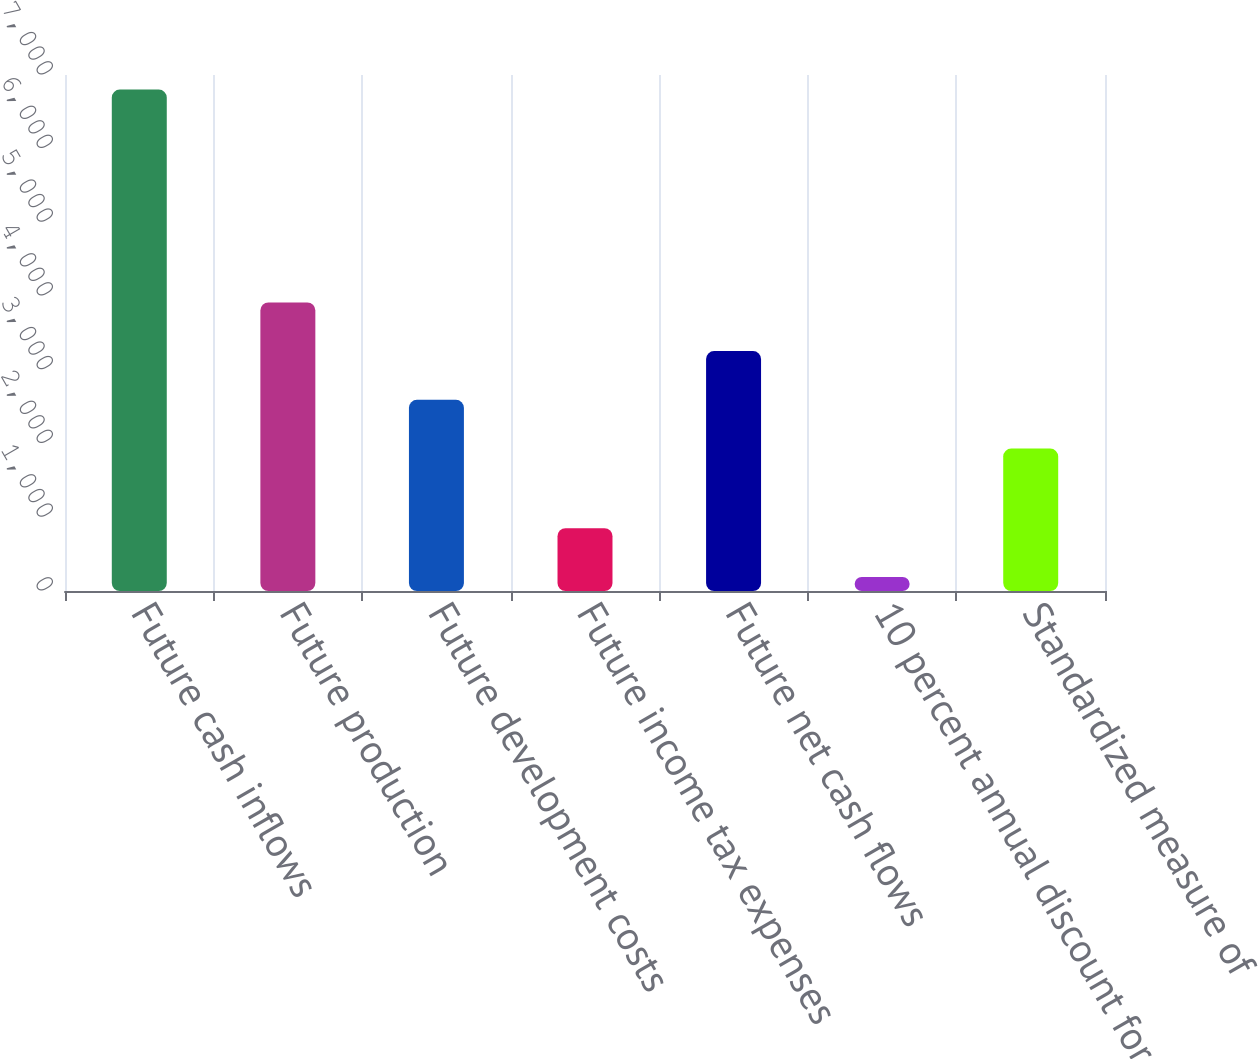Convert chart. <chart><loc_0><loc_0><loc_500><loc_500><bar_chart><fcel>Future cash inflows<fcel>Future production<fcel>Future development costs<fcel>Future income tax expenses<fcel>Future net cash flows<fcel>10 percent annual discount for<fcel>Standardized measure of<nl><fcel>6802<fcel>3915.3<fcel>2593.1<fcel>852.1<fcel>3254.2<fcel>191<fcel>1932<nl></chart> 